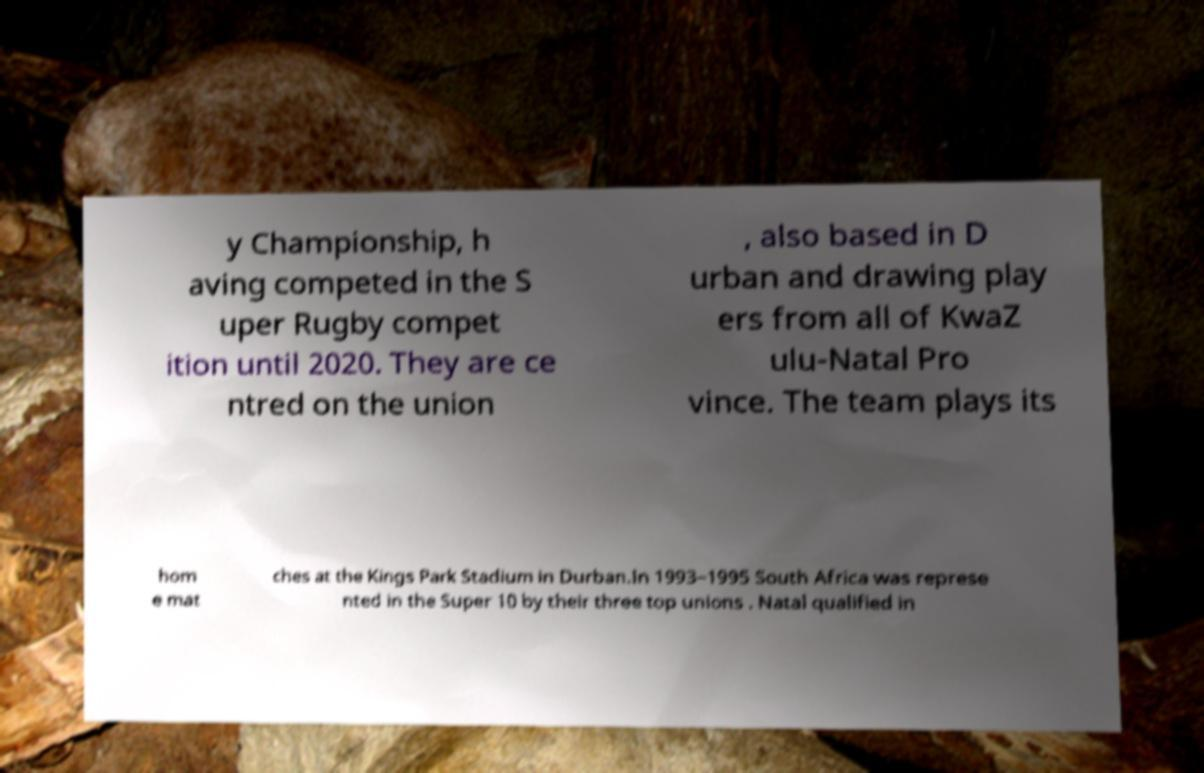Please read and relay the text visible in this image. What does it say? y Championship, h aving competed in the S uper Rugby compet ition until 2020. They are ce ntred on the union , also based in D urban and drawing play ers from all of KwaZ ulu-Natal Pro vince. The team plays its hom e mat ches at the Kings Park Stadium in Durban.In 1993–1995 South Africa was represe nted in the Super 10 by their three top unions . Natal qualified in 